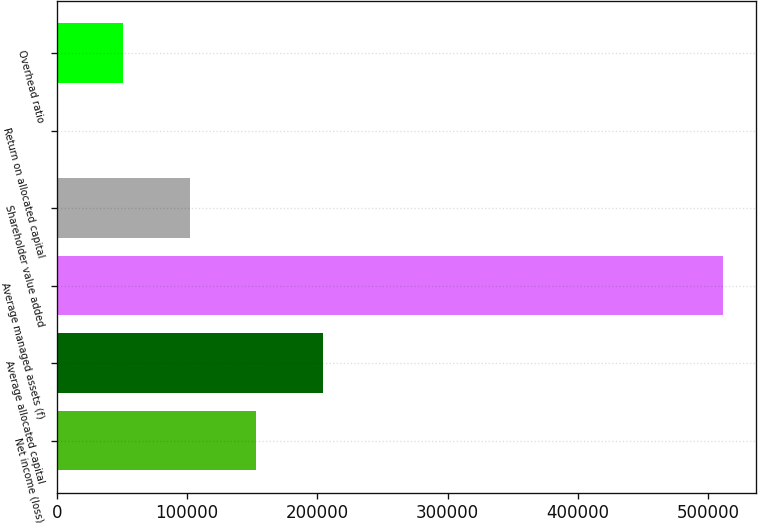Convert chart to OTSL. <chart><loc_0><loc_0><loc_500><loc_500><bar_chart><fcel>Net income (loss)<fcel>Average allocated capital<fcel>Average managed assets (f)<fcel>Shareholder value added<fcel>Return on allocated capital<fcel>Overhead ratio<nl><fcel>153282<fcel>204369<fcel>510894<fcel>102194<fcel>19<fcel>51106.5<nl></chart> 